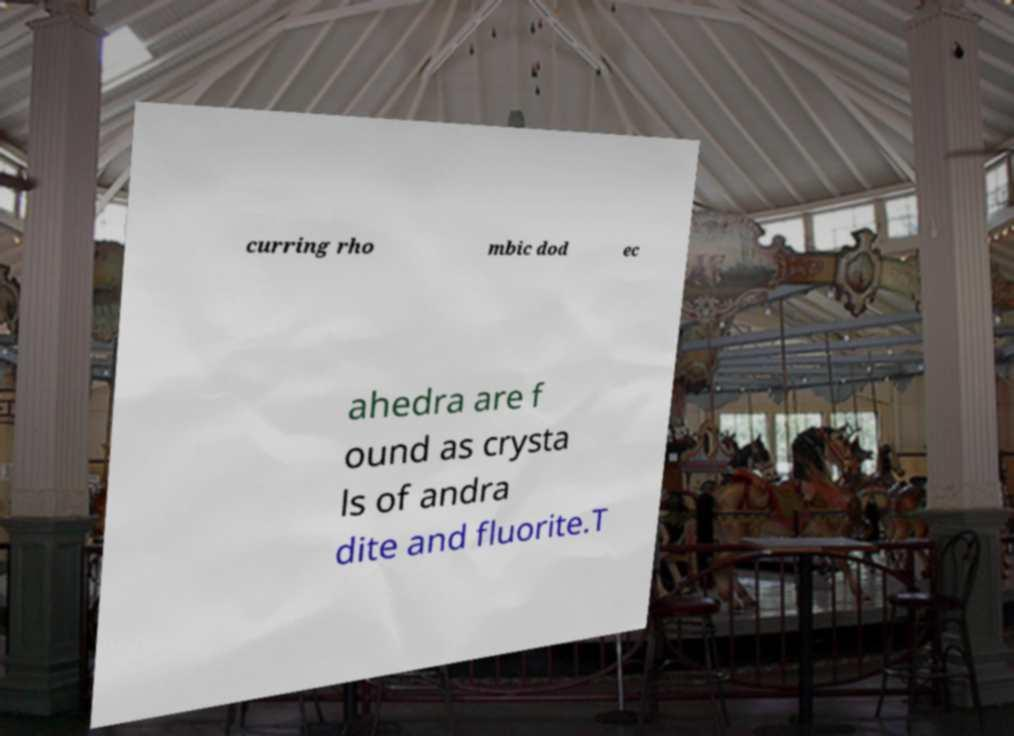Can you accurately transcribe the text from the provided image for me? curring rho mbic dod ec ahedra are f ound as crysta ls of andra dite and fluorite.T 